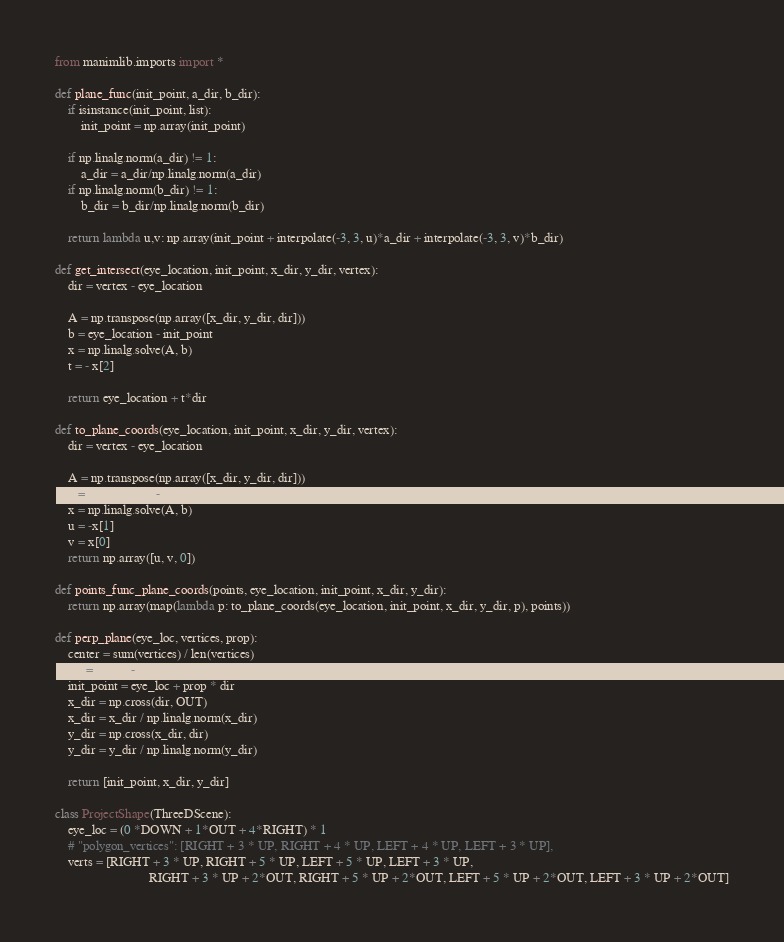<code> <loc_0><loc_0><loc_500><loc_500><_Python_>from manimlib.imports import *

def plane_func(init_point, a_dir, b_dir):
    if isinstance(init_point, list):
        init_point = np.array(init_point)

    if np.linalg.norm(a_dir) != 1:
        a_dir = a_dir/np.linalg.norm(a_dir)
    if np.linalg.norm(b_dir) != 1:
        b_dir = b_dir/np.linalg.norm(b_dir)

    return lambda u,v: np.array(init_point + interpolate(-3, 3, u)*a_dir + interpolate(-3, 3, v)*b_dir)

def get_intersect(eye_location, init_point, x_dir, y_dir, vertex):
    dir = vertex - eye_location

    A = np.transpose(np.array([x_dir, y_dir, dir]))
    b = eye_location - init_point
    x = np.linalg.solve(A, b)
    t = - x[2]

    return eye_location + t*dir

def to_plane_coords(eye_location, init_point, x_dir, y_dir, vertex):
    dir = vertex - eye_location

    A = np.transpose(np.array([x_dir, y_dir, dir]))
    b = eye_location - init_point
    x = np.linalg.solve(A, b)
    u = -x[1]
    v = x[0]
    return np.array([u, v, 0])

def points_func_plane_coords(points, eye_location, init_point, x_dir, y_dir):
    return np.array(map(lambda p: to_plane_coords(eye_location, init_point, x_dir, y_dir, p), points))

def perp_plane(eye_loc, vertices, prop):
    center = sum(vertices) / len(vertices)
    dir = center - eye_loc
    init_point = eye_loc + prop * dir
    x_dir = np.cross(dir, OUT)
    x_dir = x_dir / np.linalg.norm(x_dir)
    y_dir = np.cross(x_dir, dir)
    y_dir = y_dir / np.linalg.norm(y_dir)

    return [init_point, x_dir, y_dir]

class ProjectShape(ThreeDScene):
    eye_loc = (0 *DOWN + 1*OUT + 4*RIGHT) * 1
    # "polygon_vertices": [RIGHT + 3 * UP, RIGHT + 4 * UP, LEFT + 4 * UP, LEFT + 3 * UP],
    verts = [RIGHT + 3 * UP, RIGHT + 5 * UP, LEFT + 5 * UP, LEFT + 3 * UP,
                             RIGHT + 3 * UP + 2*OUT, RIGHT + 5 * UP + 2*OUT, LEFT + 5 * UP + 2*OUT, LEFT + 3 * UP + 2*OUT]
</code> 